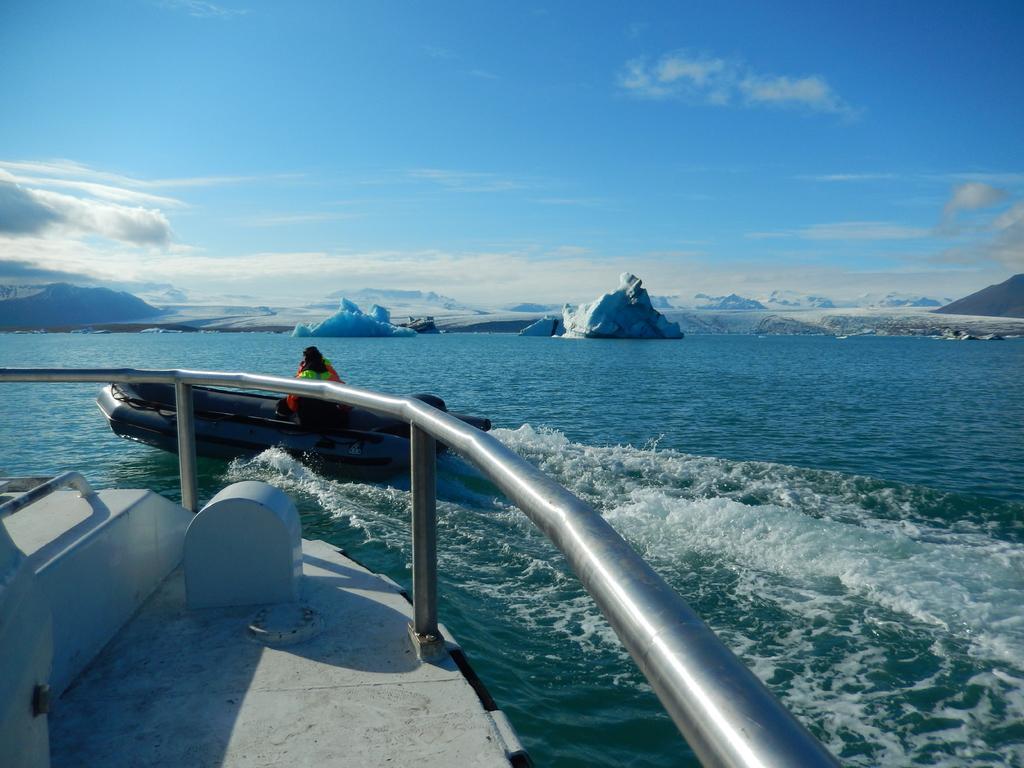Describe this image in one or two sentences. In this image there is a ship on the river, in front of the ship there is a person on the boat. In the background there are mountains and the sky. 